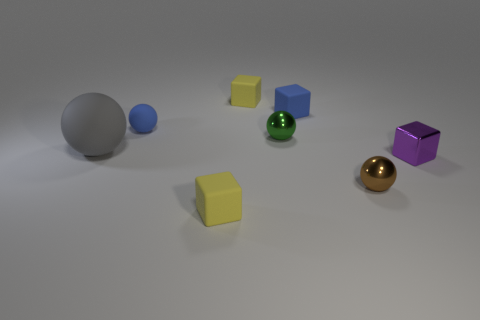How many things are small blue objects or red spheres?
Give a very brief answer. 2. There is a tiny yellow rubber block behind the green thing; is there a tiny brown metallic thing that is left of it?
Your answer should be very brief. No. Are there more cubes that are right of the green metallic thing than tiny rubber objects behind the big gray ball?
Give a very brief answer. No. There is a tiny object that is the same color as the tiny matte ball; what material is it?
Your answer should be compact. Rubber. How many small objects are the same color as the big object?
Give a very brief answer. 0. Is the color of the big thing that is behind the metal block the same as the small shiny object that is behind the gray rubber object?
Your response must be concise. No. There is a tiny purple metal thing; are there any tiny things on the right side of it?
Offer a very short reply. No. What material is the tiny blue ball?
Give a very brief answer. Rubber. There is a yellow thing in front of the green sphere; what shape is it?
Provide a succinct answer. Cube. There is a rubber object that is the same color as the small rubber ball; what is its size?
Your answer should be compact. Small. 